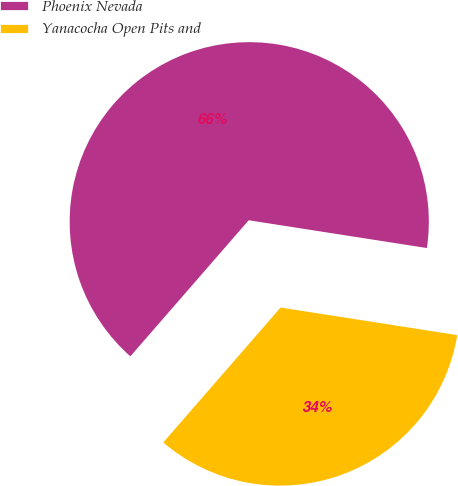<chart> <loc_0><loc_0><loc_500><loc_500><pie_chart><fcel>Phoenix Nevada<fcel>Yanacocha Open Pits and<nl><fcel>66.07%<fcel>33.93%<nl></chart> 